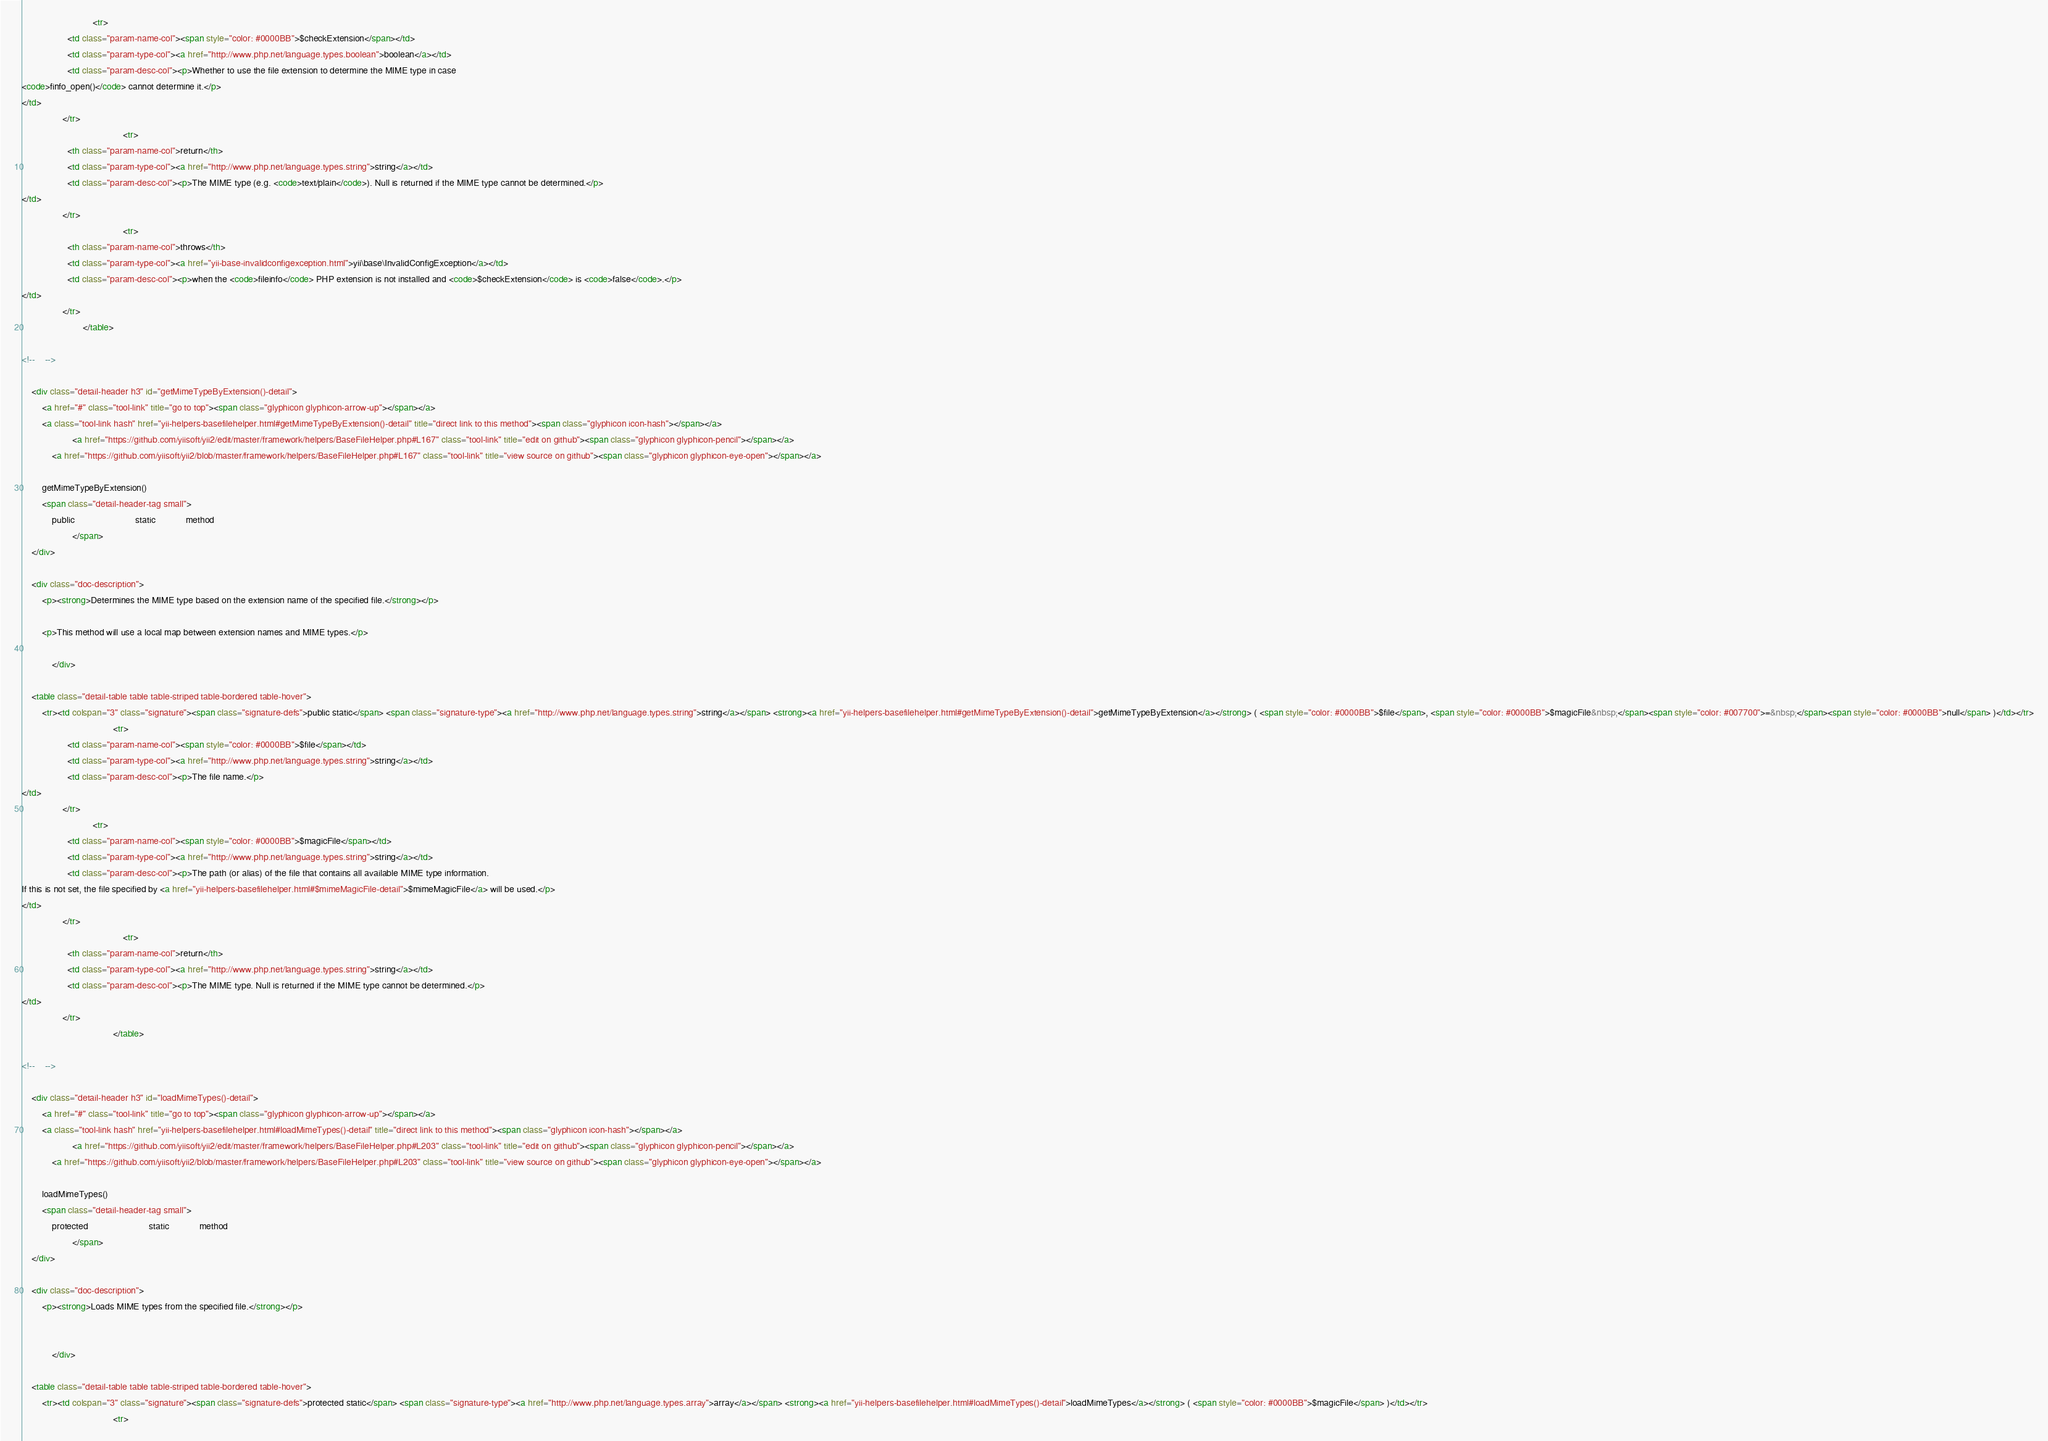<code> <loc_0><loc_0><loc_500><loc_500><_HTML_>                            <tr>
                  <td class="param-name-col"><span style="color: #0000BB">$checkExtension</span></td>
                  <td class="param-type-col"><a href="http://www.php.net/language.types.boolean">boolean</a></td>
                  <td class="param-desc-col"><p>Whether to use the file extension to determine the MIME type in case
<code>finfo_open()</code> cannot determine it.</p>
</td>
                </tr>
                                        <tr>
                  <th class="param-name-col">return</th>
                  <td class="param-type-col"><a href="http://www.php.net/language.types.string">string</a></td>
                  <td class="param-desc-col"><p>The MIME type (e.g. <code>text/plain</code>). Null is returned if the MIME type cannot be determined.</p>
</td>
                </tr>
                                        <tr>
                  <th class="param-name-col">throws</th>
                  <td class="param-type-col"><a href="yii-base-invalidconfigexception.html">yii\base\InvalidConfigException</a></td>
                  <td class="param-desc-col"><p>when the <code>fileinfo</code> PHP extension is not installed and <code>$checkExtension</code> is <code>false</code>.</p>
</td>
                </tr>
                        </table>

<!--	-->

    <div class="detail-header h3" id="getMimeTypeByExtension()-detail">
        <a href="#" class="tool-link" title="go to top"><span class="glyphicon glyphicon-arrow-up"></span></a>
        <a class="tool-link hash" href="yii-helpers-basefilehelper.html#getMimeTypeByExtension()-detail" title="direct link to this method"><span class="glyphicon icon-hash"></span></a>
                    <a href="https://github.com/yiisoft/yii2/edit/master/framework/helpers/BaseFileHelper.php#L167" class="tool-link" title="edit on github"><span class="glyphicon glyphicon-pencil"></span></a>
            <a href="https://github.com/yiisoft/yii2/blob/master/framework/helpers/BaseFileHelper.php#L167" class="tool-link" title="view source on github"><span class="glyphicon glyphicon-eye-open"></span></a>
        
        getMimeTypeByExtension()
        <span class="detail-header-tag small">
            public                        static            method
                    </span>
    </div>

    <div class="doc-description">
        <p><strong>Determines the MIME type based on the extension name of the specified file.</strong></p>

        <p>This method will use a local map between extension names and MIME types.</p>

            </div>

    <table class="detail-table table table-striped table-bordered table-hover">
        <tr><td colspan="3" class="signature"><span class="signature-defs">public static</span> <span class="signature-type"><a href="http://www.php.net/language.types.string">string</a></span> <strong><a href="yii-helpers-basefilehelper.html#getMimeTypeByExtension()-detail">getMimeTypeByExtension</a></strong> ( <span style="color: #0000BB">$file</span>, <span style="color: #0000BB">$magicFile&nbsp;</span><span style="color: #007700">=&nbsp;</span><span style="color: #0000BB">null</span> )</td></tr>
                                    <tr>
                  <td class="param-name-col"><span style="color: #0000BB">$file</span></td>
                  <td class="param-type-col"><a href="http://www.php.net/language.types.string">string</a></td>
                  <td class="param-desc-col"><p>The file name.</p>
</td>
                </tr>
                            <tr>
                  <td class="param-name-col"><span style="color: #0000BB">$magicFile</span></td>
                  <td class="param-type-col"><a href="http://www.php.net/language.types.string">string</a></td>
                  <td class="param-desc-col"><p>The path (or alias) of the file that contains all available MIME type information.
If this is not set, the file specified by <a href="yii-helpers-basefilehelper.html#$mimeMagicFile-detail">$mimeMagicFile</a> will be used.</p>
</td>
                </tr>
                                        <tr>
                  <th class="param-name-col">return</th>
                  <td class="param-type-col"><a href="http://www.php.net/language.types.string">string</a></td>
                  <td class="param-desc-col"><p>The MIME type. Null is returned if the MIME type cannot be determined.</p>
</td>
                </tr>
                                    </table>

<!--	-->

    <div class="detail-header h3" id="loadMimeTypes()-detail">
        <a href="#" class="tool-link" title="go to top"><span class="glyphicon glyphicon-arrow-up"></span></a>
        <a class="tool-link hash" href="yii-helpers-basefilehelper.html#loadMimeTypes()-detail" title="direct link to this method"><span class="glyphicon icon-hash"></span></a>
                    <a href="https://github.com/yiisoft/yii2/edit/master/framework/helpers/BaseFileHelper.php#L203" class="tool-link" title="edit on github"><span class="glyphicon glyphicon-pencil"></span></a>
            <a href="https://github.com/yiisoft/yii2/blob/master/framework/helpers/BaseFileHelper.php#L203" class="tool-link" title="view source on github"><span class="glyphicon glyphicon-eye-open"></span></a>
        
        loadMimeTypes()
        <span class="detail-header-tag small">
            protected                        static            method
                    </span>
    </div>

    <div class="doc-description">
        <p><strong>Loads MIME types from the specified file.</strong></p>

        
            </div>

    <table class="detail-table table table-striped table-bordered table-hover">
        <tr><td colspan="3" class="signature"><span class="signature-defs">protected static</span> <span class="signature-type"><a href="http://www.php.net/language.types.array">array</a></span> <strong><a href="yii-helpers-basefilehelper.html#loadMimeTypes()-detail">loadMimeTypes</a></strong> ( <span style="color: #0000BB">$magicFile</span> )</td></tr>
                                    <tr></code> 